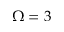<formula> <loc_0><loc_0><loc_500><loc_500>\Omega = 3</formula> 